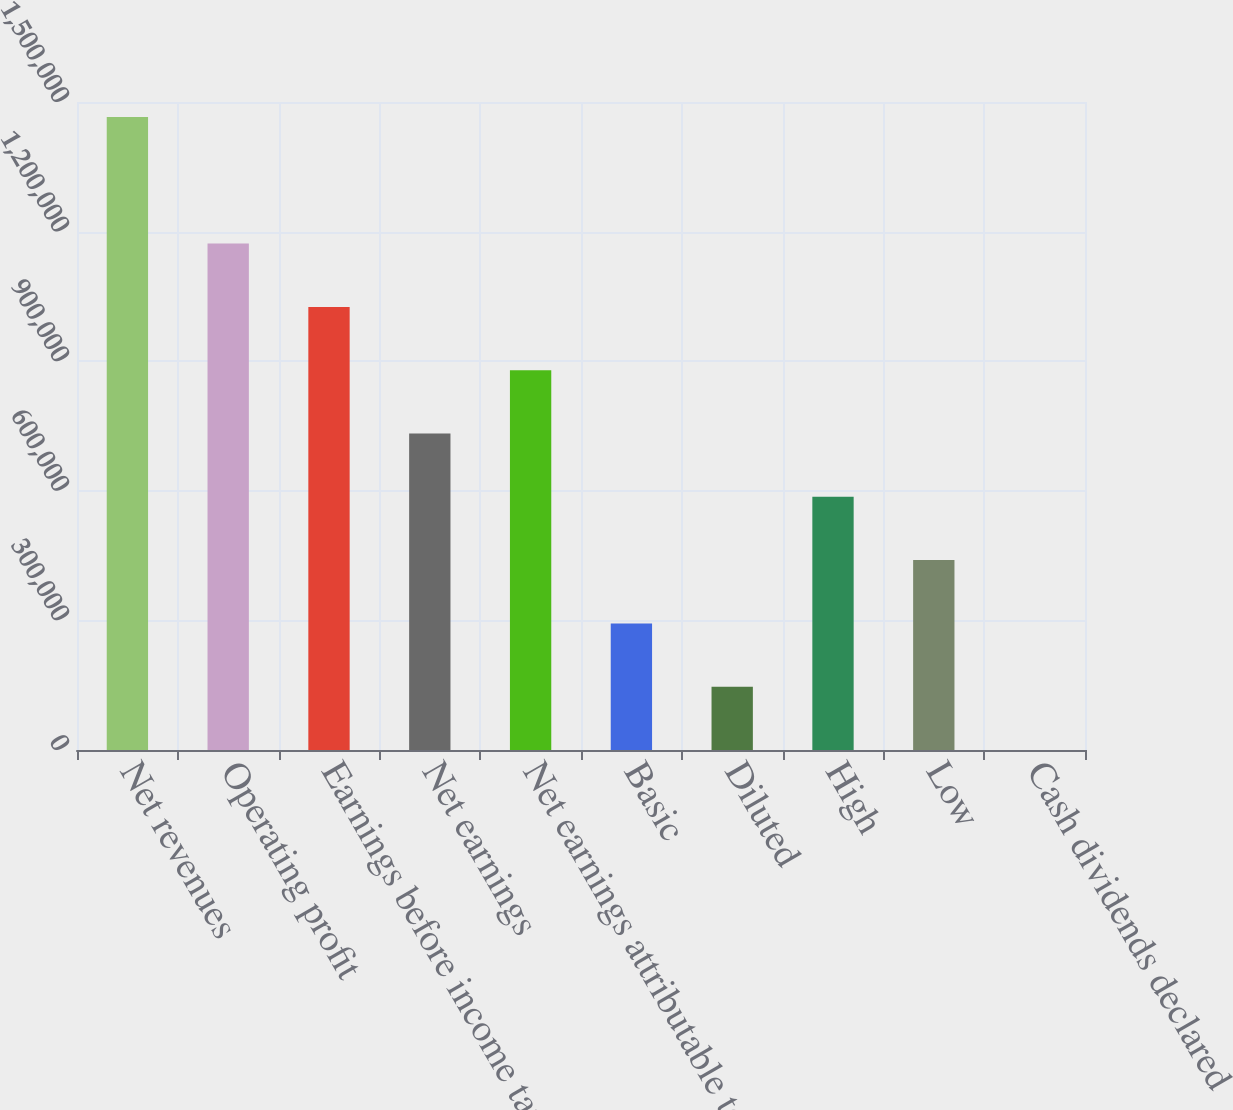<chart> <loc_0><loc_0><loc_500><loc_500><bar_chart><fcel>Net revenues<fcel>Operating profit<fcel>Earnings before income taxes<fcel>Net earnings<fcel>Net earnings attributable to<fcel>Basic<fcel>Diluted<fcel>High<fcel>Low<fcel>Cash dividends declared<nl><fcel>1.46535e+06<fcel>1.17228e+06<fcel>1.02575e+06<fcel>732677<fcel>879213<fcel>293071<fcel>146536<fcel>586142<fcel>439607<fcel>0.46<nl></chart> 